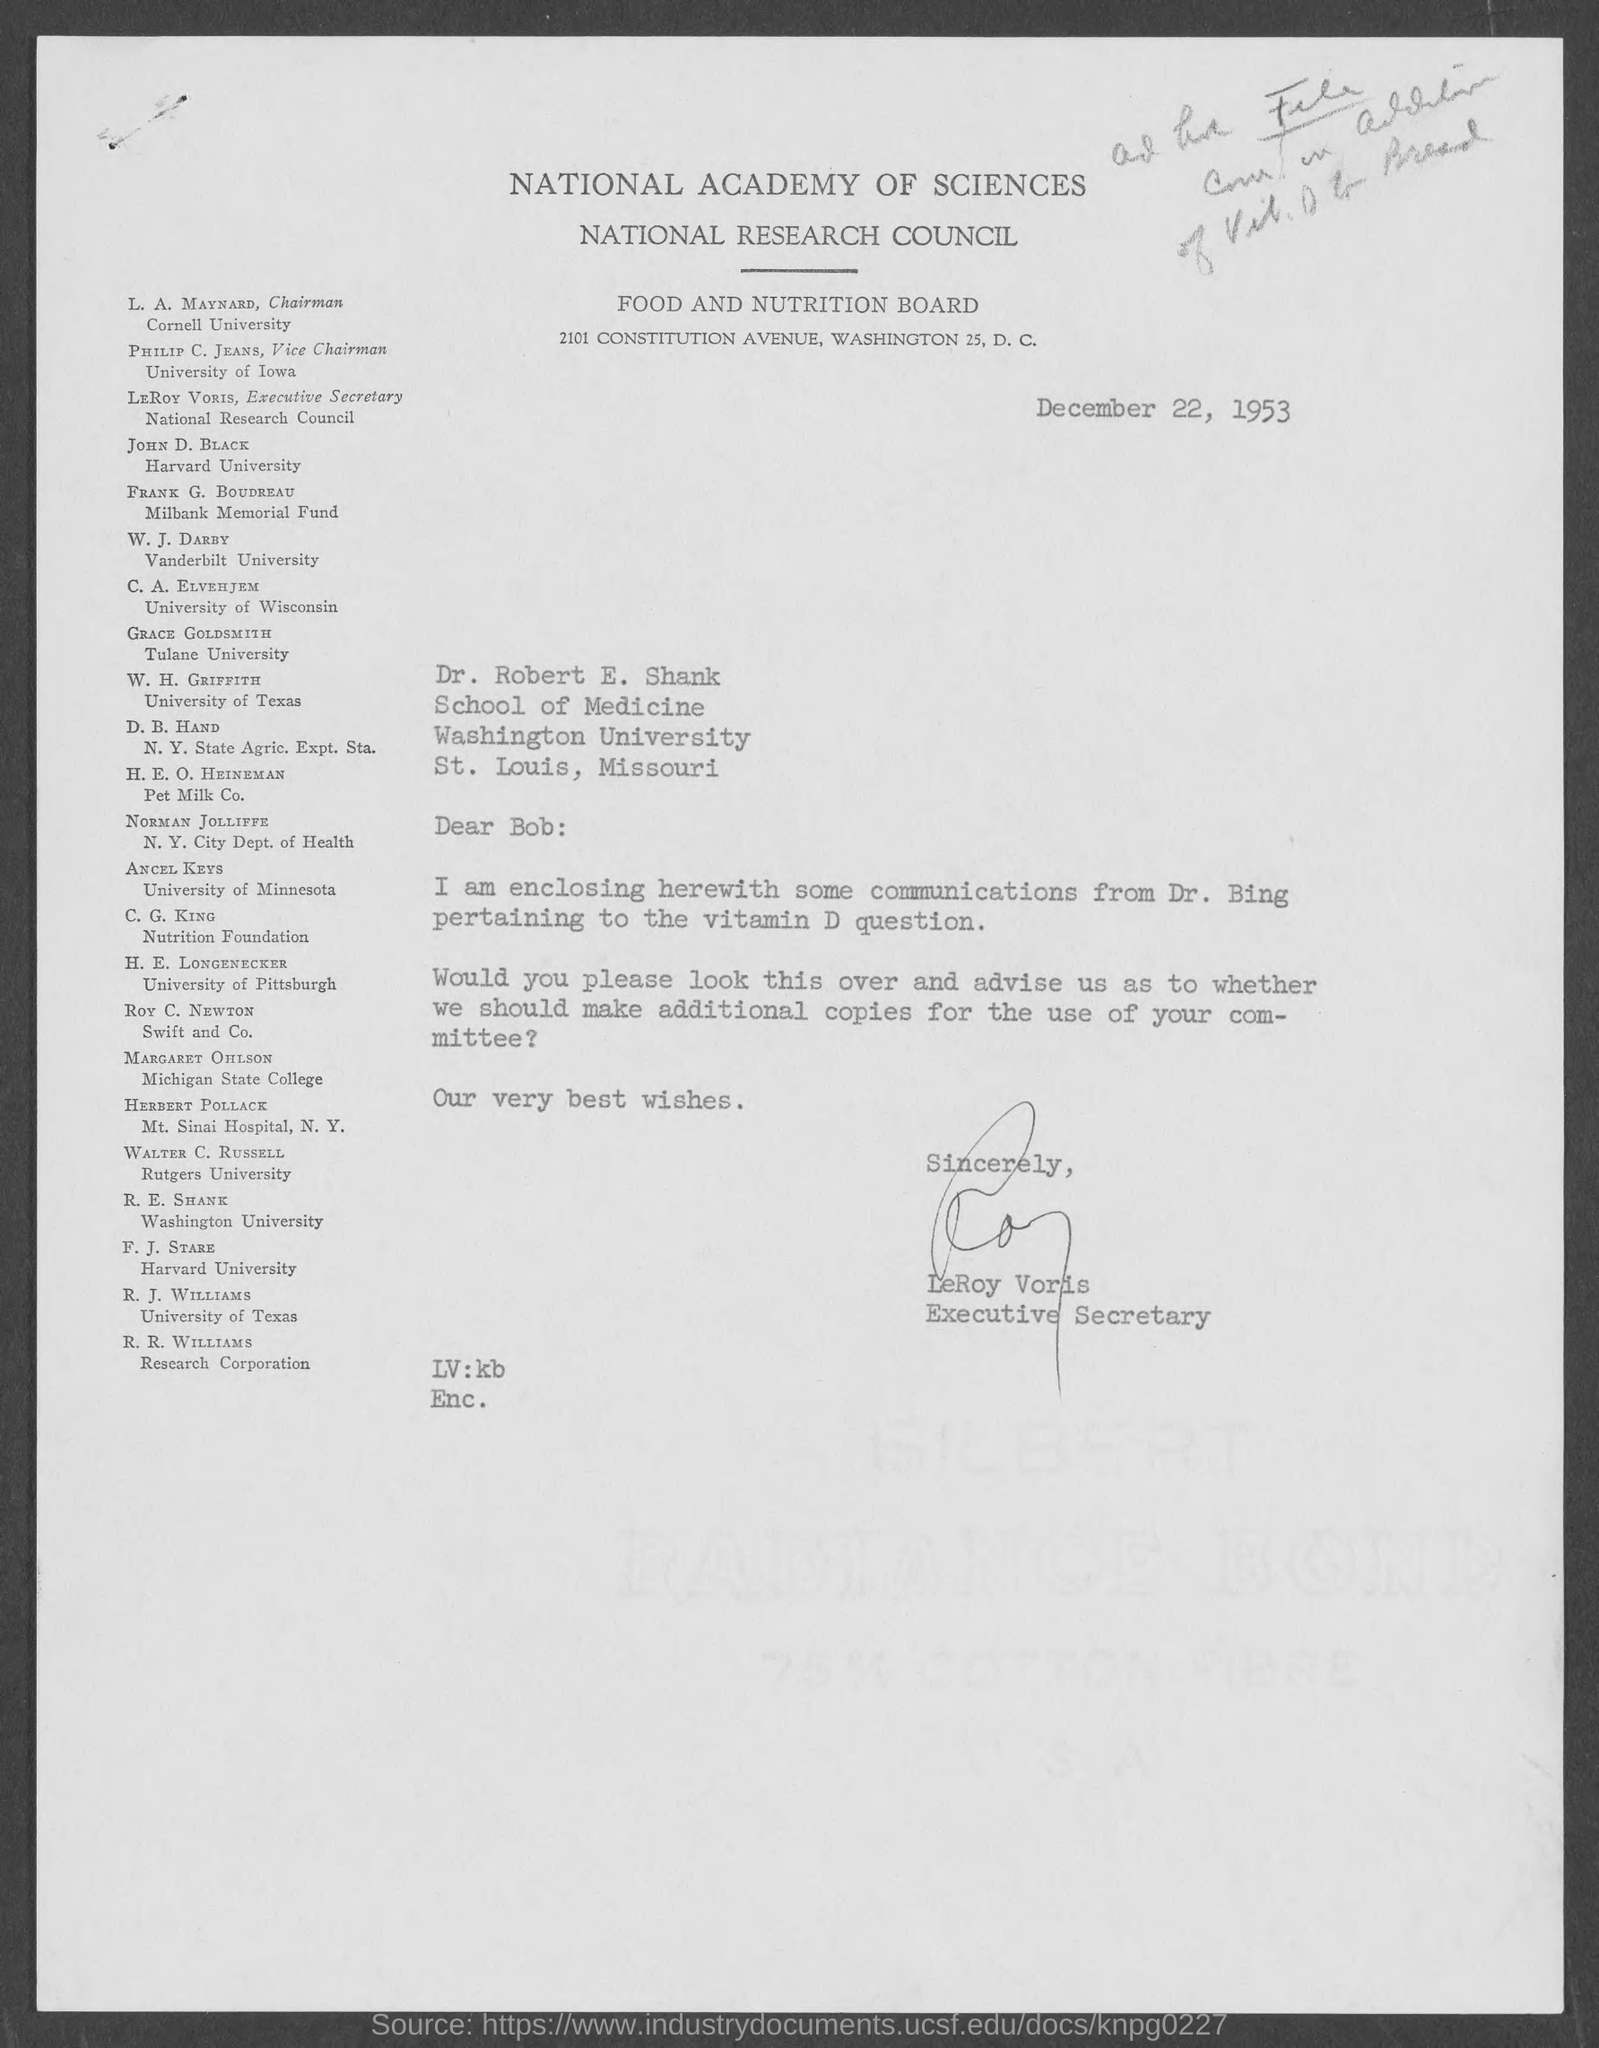Who is the chairman, cornell university ?
Make the answer very short. L. A. Maynard. Who is executive secretary, national research council ?
Your answer should be compact. LeRoy Voris. The letter is dated on?
Your answer should be compact. December 22, 1953. To which university does w. j. darby belong ?
Ensure brevity in your answer.  Vanderbilt University. To which university does c.a. elvehjem belong ?
Your answer should be very brief. University of Wisconsin. To which university does w. h. griffith belong?
Make the answer very short. University of Texas. To which university does ancel keys belong?
Your response must be concise. University of Minnesota. 